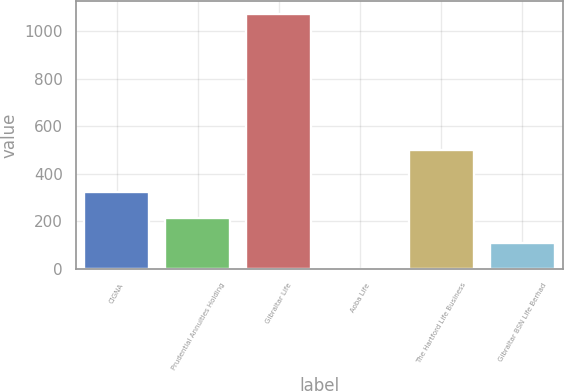Convert chart to OTSL. <chart><loc_0><loc_0><loc_500><loc_500><bar_chart><fcel>CIGNA<fcel>Prudential Annuities Holding<fcel>Gibraltar Life<fcel>Aoba Life<fcel>The Hartford Life Business<fcel>Gibraltar BSN Life Berhad<nl><fcel>322.05<fcel>215.06<fcel>1071<fcel>1.08<fcel>500<fcel>108.07<nl></chart> 